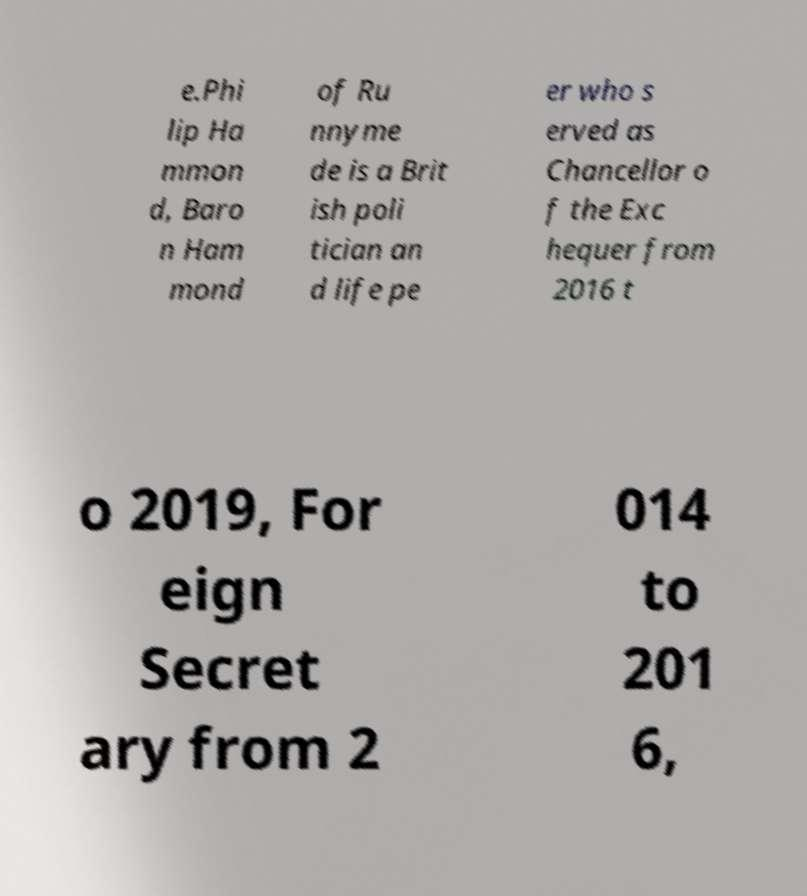Could you assist in decoding the text presented in this image and type it out clearly? e.Phi lip Ha mmon d, Baro n Ham mond of Ru nnyme de is a Brit ish poli tician an d life pe er who s erved as Chancellor o f the Exc hequer from 2016 t o 2019, For eign Secret ary from 2 014 to 201 6, 